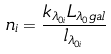<formula> <loc_0><loc_0><loc_500><loc_500>n _ { i } = \frac { k _ { \lambda _ { 0 i } } L _ { \lambda _ { 0 } { g a l } } } { l _ { \lambda _ { 0 i } } }</formula> 